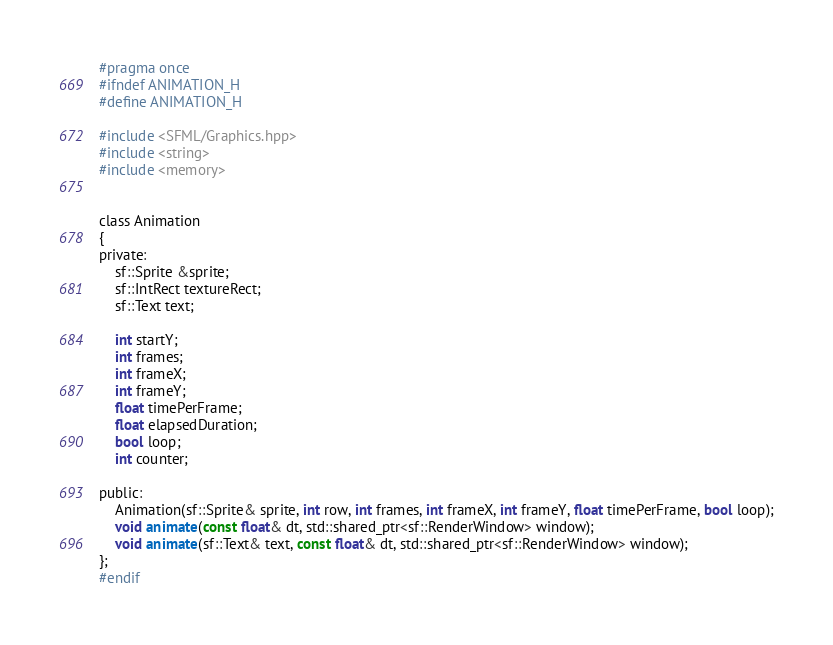Convert code to text. <code><loc_0><loc_0><loc_500><loc_500><_C_>#pragma once
#ifndef ANIMATION_H
#define ANIMATION_H

#include <SFML/Graphics.hpp>
#include <string>
#include <memory>


class Animation
{
private:
    sf::Sprite &sprite;
    sf::IntRect textureRect;
    sf::Text text;

    int startY;
    int frames;
    int frameX;
    int frameY;
    float timePerFrame;
    float elapsedDuration;
    bool loop;
    int counter;

public:
    Animation(sf::Sprite& sprite, int row, int frames, int frameX, int frameY, float timePerFrame, bool loop);
    void animate(const float& dt, std::shared_ptr<sf::RenderWindow> window);
    void animate(sf::Text& text, const float& dt, std::shared_ptr<sf::RenderWindow> window);
};
#endif</code> 